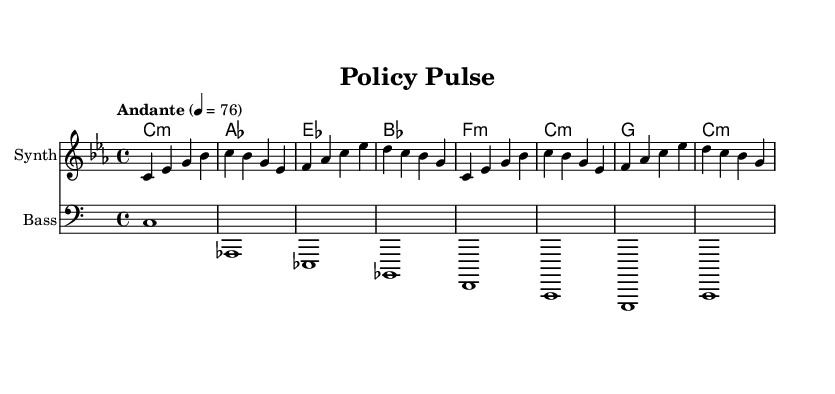What is the key signature of this music? The key signature is C minor, which has three flats (B, E, and A) indicated on the staff.
Answer: C minor What is the time signature of this music? The time signature is indicated at the beginning of the piece, showing that there are four beats in each measure.
Answer: 4/4 What is the tempo marking of this piece? The tempo marking written above the staff indicates that the piece should be played at a moderately slow speed of 76 beats per minute.
Answer: Andante 76 How many measures are present in the melody? By counting the individual measures in the melody part, we find that there are a total of eight measures.
Answer: 8 What type of music is represented in this sheet? The harmony and instrumentation suggest that this music belongs to the ambient electronic genre, aimed at creating a calm and focused atmosphere.
Answer: Ambient electronic Which instrument is responsible for the melody? The instrument that is designated to perform the melody is labeled as "Synth," which typically implies a synthesized sound commonly used in electronic music.
Answer: Synth What is the relationship between the bass and melody parts? The bass part provides a foundational support for the melody, reinforcing harmonic structure and rhythm, which is essential for ambient electronic music.
Answer: Supportive 